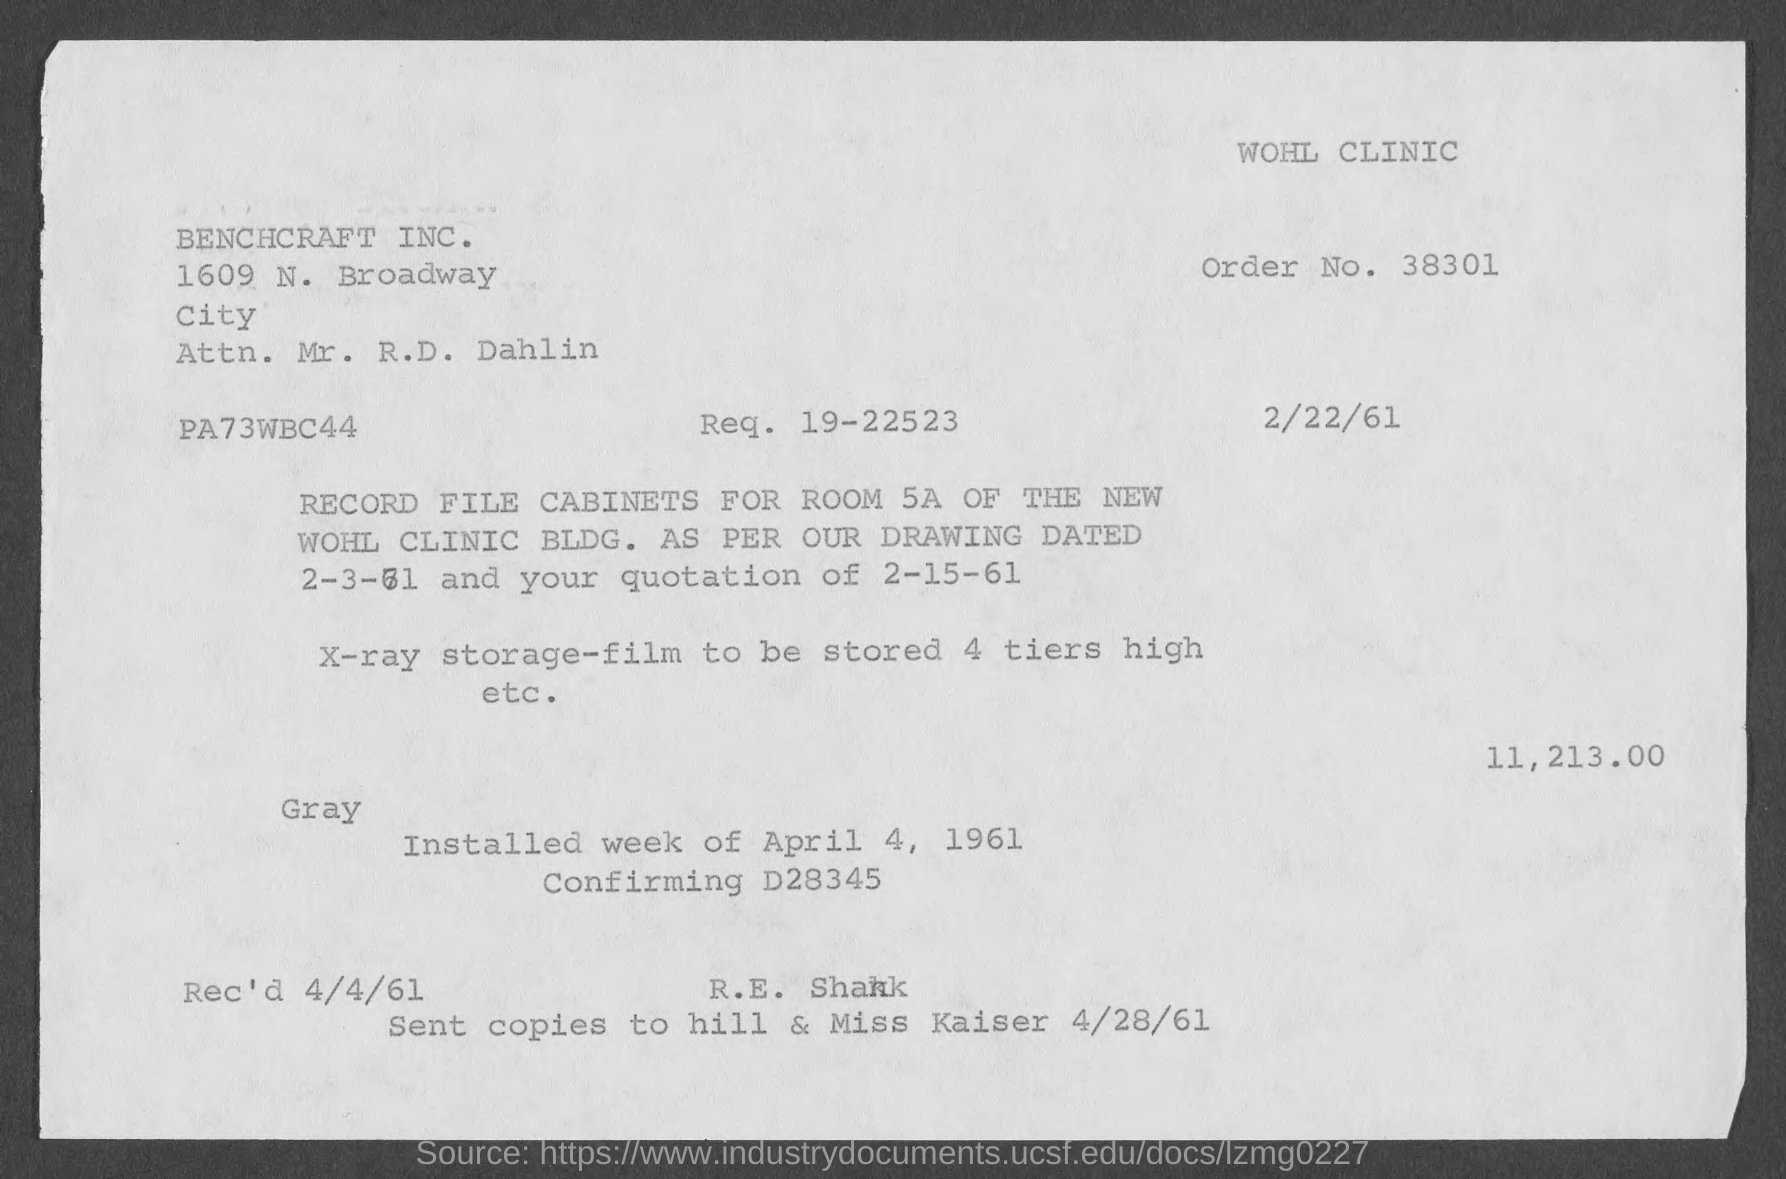What is the order no.?
Provide a succinct answer. 38301. What is req. no.?
Your answer should be compact. 19-22523. What is the date in the bill ?
Your response must be concise. 2/22/61. 